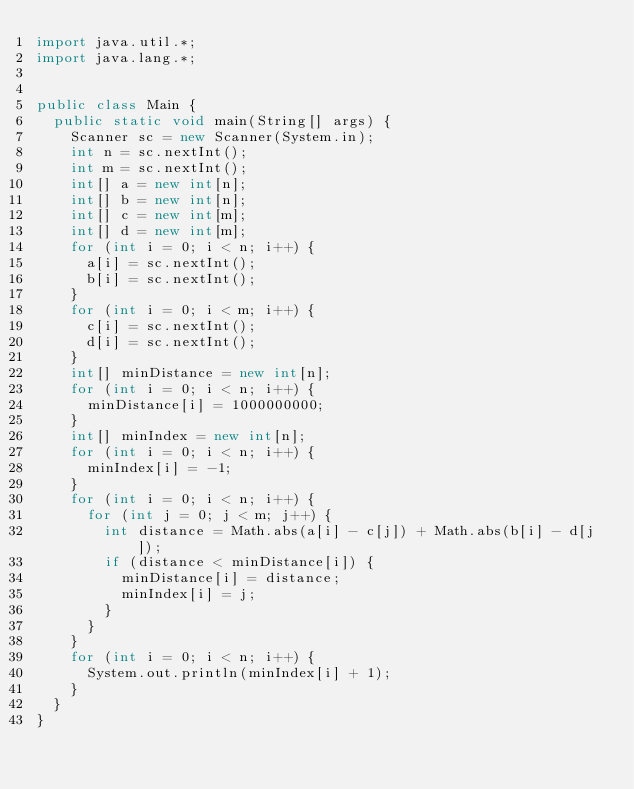<code> <loc_0><loc_0><loc_500><loc_500><_Java_>import java.util.*;
import java.lang.*;


public class Main {
	public static void main(String[] args) {
		Scanner sc = new Scanner(System.in);
		int n = sc.nextInt();
		int m = sc.nextInt();
		int[] a = new int[n];
		int[] b = new int[n];
		int[] c = new int[m];
		int[] d = new int[m];
		for (int i = 0; i < n; i++) {
			a[i] = sc.nextInt();
			b[i] = sc.nextInt();
		}
		for (int i = 0; i < m; i++) {
			c[i] = sc.nextInt();
			d[i] = sc.nextInt();
		}
		int[] minDistance = new int[n];
		for (int i = 0; i < n; i++) {
			minDistance[i] = 1000000000;
		}
		int[] minIndex = new int[n];
		for (int i = 0; i < n; i++) {
			minIndex[i] = -1;
		}
		for (int i = 0; i < n; i++) {
			for (int j = 0; j < m; j++) {
				int distance = Math.abs(a[i] - c[j]) + Math.abs(b[i] - d[j]);
				if (distance < minDistance[i]) {
					minDistance[i] = distance;
					minIndex[i] = j;
				}
			}
		}
		for (int i = 0; i < n; i++) {
			System.out.println(minIndex[i] + 1);
		}
	}
}</code> 